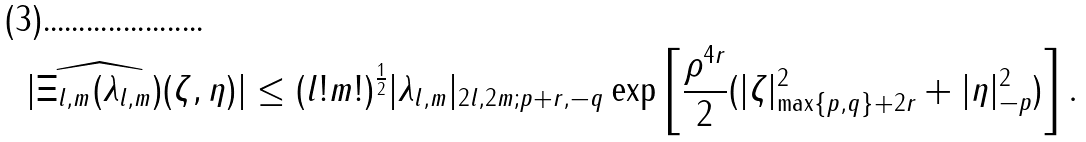Convert formula to latex. <formula><loc_0><loc_0><loc_500><loc_500>| \widehat { \Xi _ { l , m } ( \lambda _ { l , m } ) } ( \zeta , \eta ) | \leq ( l ! m ! ) ^ { \frac { 1 } { 2 } } | \lambda _ { l , m } | _ { 2 l , 2 m ; p + r , - q } \exp \left [ \frac { \rho ^ { 4 r } } { 2 } ( | \zeta | _ { \max \{ p , q \} + 2 r } ^ { 2 } + | \eta | _ { - p } ^ { 2 } ) \right ] .</formula> 